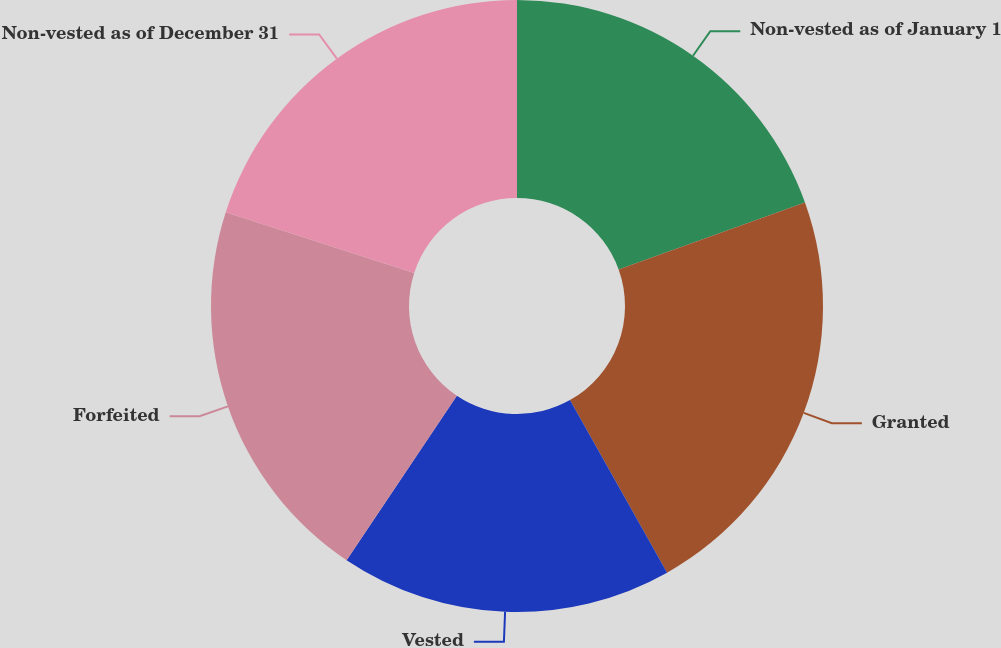<chart> <loc_0><loc_0><loc_500><loc_500><pie_chart><fcel>Non-vested as of January 1<fcel>Granted<fcel>Vested<fcel>Forfeited<fcel>Non-vested as of December 31<nl><fcel>19.51%<fcel>22.33%<fcel>17.56%<fcel>20.56%<fcel>20.04%<nl></chart> 